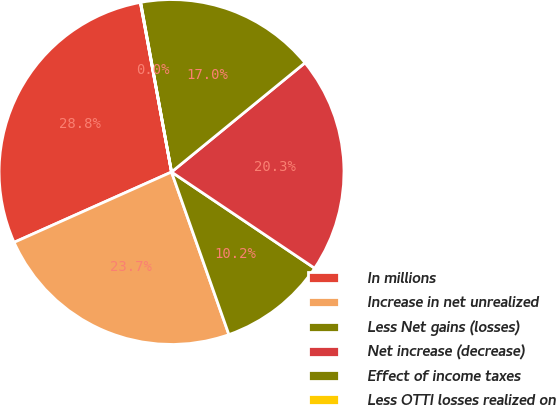Convert chart to OTSL. <chart><loc_0><loc_0><loc_500><loc_500><pie_chart><fcel>In millions<fcel>Increase in net unrealized<fcel>Less Net gains (losses)<fcel>Net increase (decrease)<fcel>Effect of income taxes<fcel>Less OTTI losses realized on<nl><fcel>28.79%<fcel>23.71%<fcel>10.18%<fcel>20.33%<fcel>16.95%<fcel>0.03%<nl></chart> 